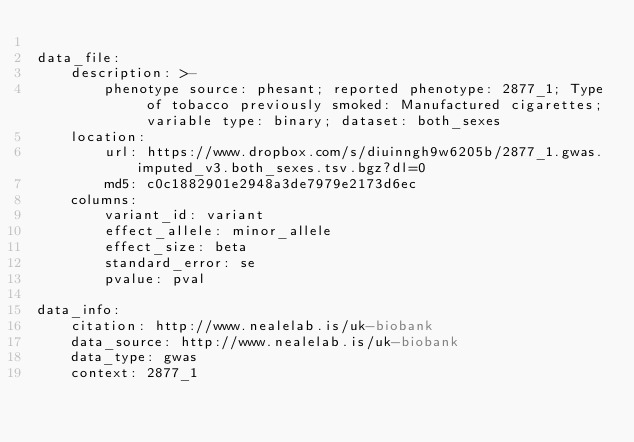<code> <loc_0><loc_0><loc_500><loc_500><_YAML_>
data_file:
    description: >-
        phenotype source: phesant; reported phenotype: 2877_1; Type of tobacco previously smoked: Manufactured cigarettes; variable type: binary; dataset: both_sexes
    location:
        url: https://www.dropbox.com/s/diuinngh9w6205b/2877_1.gwas.imputed_v3.both_sexes.tsv.bgz?dl=0
        md5: c0c1882901e2948a3de7979e2173d6ec
    columns:
        variant_id: variant
        effect_allele: minor_allele
        effect_size: beta
        standard_error: se
        pvalue: pval

data_info:
    citation: http://www.nealelab.is/uk-biobank
    data_source: http://www.nealelab.is/uk-biobank
    data_type: gwas
    context: 2877_1</code> 